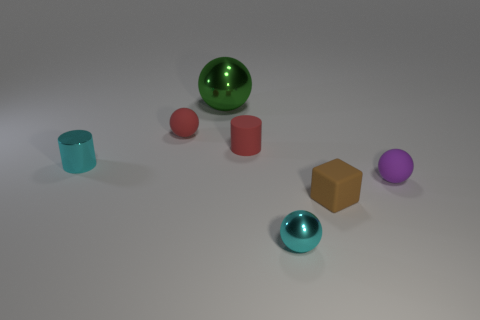What number of tiny cyan metallic objects have the same shape as the green shiny thing?
Provide a short and direct response. 1. What material is the brown cube?
Offer a very short reply. Rubber. Do the big sphere and the tiny shiny thing that is in front of the purple matte object have the same color?
Make the answer very short. No. How many spheres are either large red shiny things or purple matte things?
Offer a very short reply. 1. There is a small matte thing right of the small brown rubber cube; what color is it?
Provide a succinct answer. Purple. There is a metallic thing that is the same color as the tiny metal cylinder; what shape is it?
Provide a succinct answer. Sphere. How many red balls are the same size as the purple thing?
Make the answer very short. 1. Do the small metal object that is behind the tiny brown block and the tiny cyan object that is in front of the small purple ball have the same shape?
Ensure brevity in your answer.  No. The tiny ball right of the small cyan object that is in front of the small shiny object behind the tiny cyan ball is made of what material?
Your answer should be very brief. Rubber. The brown thing that is the same size as the purple thing is what shape?
Offer a terse response. Cube. 